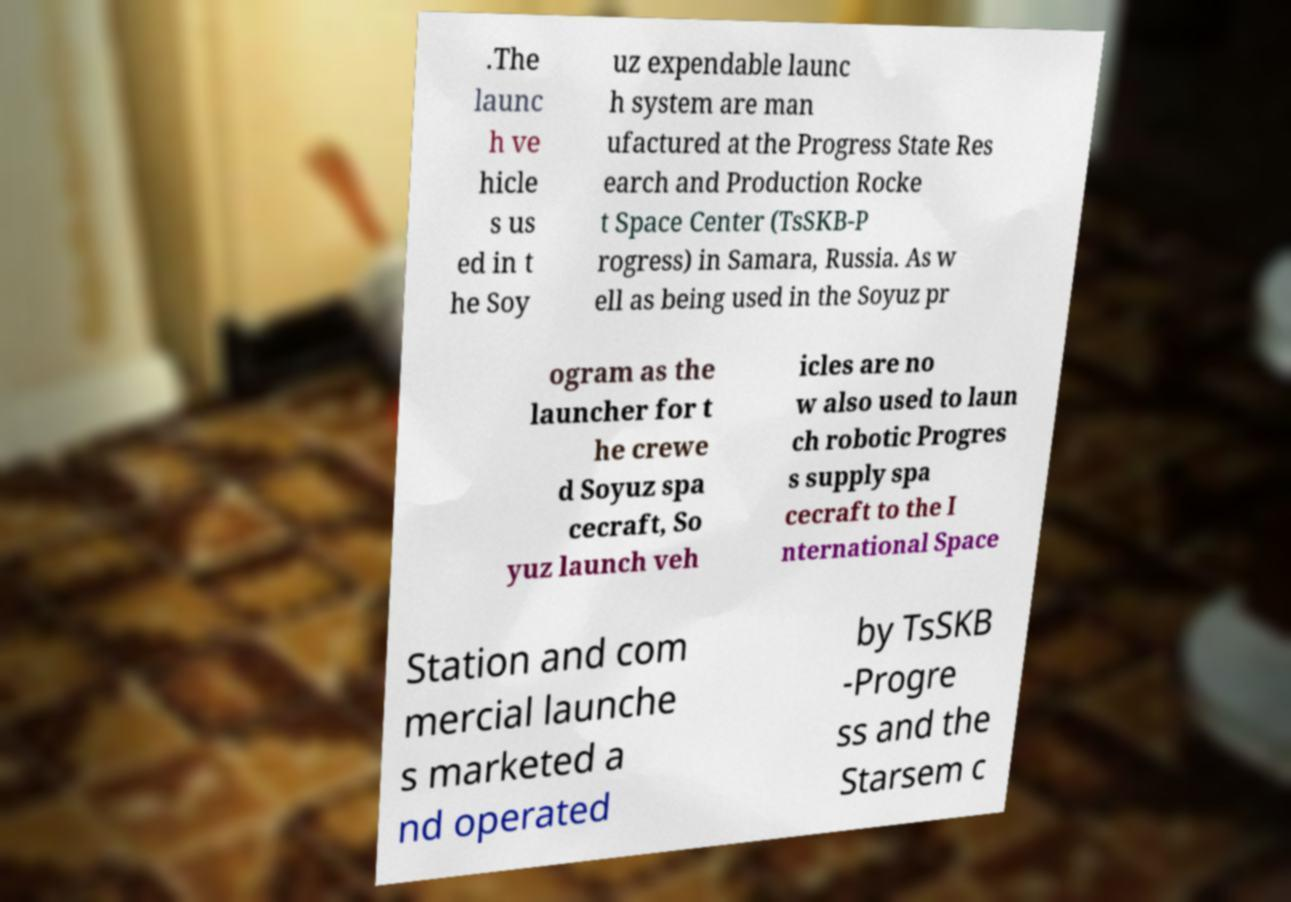Please read and relay the text visible in this image. What does it say? .The launc h ve hicle s us ed in t he Soy uz expendable launc h system are man ufactured at the Progress State Res earch and Production Rocke t Space Center (TsSKB-P rogress) in Samara, Russia. As w ell as being used in the Soyuz pr ogram as the launcher for t he crewe d Soyuz spa cecraft, So yuz launch veh icles are no w also used to laun ch robotic Progres s supply spa cecraft to the I nternational Space Station and com mercial launche s marketed a nd operated by TsSKB -Progre ss and the Starsem c 